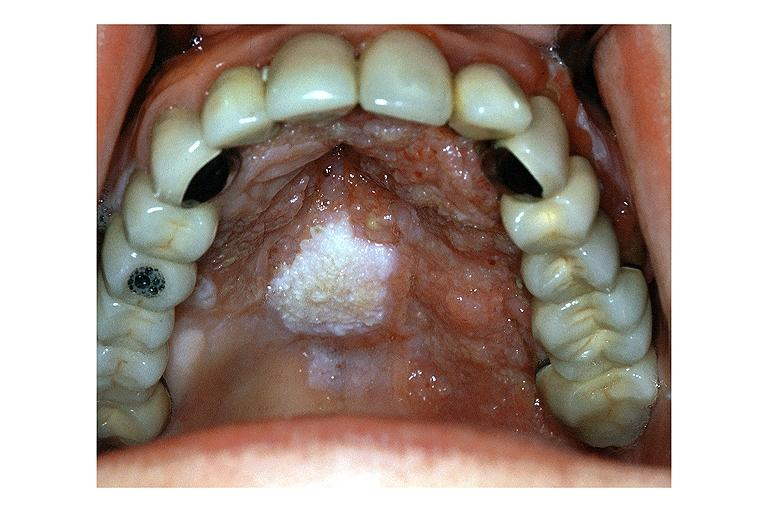s stillborn macerated present?
Answer the question using a single word or phrase. No 